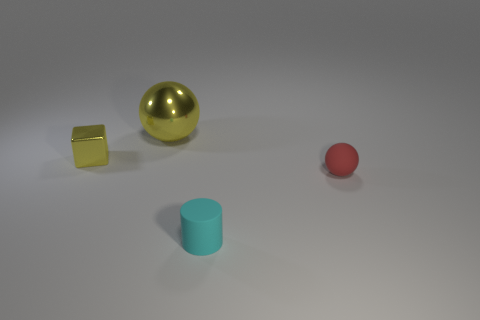What shape is the thing that is both right of the yellow ball and behind the small cyan matte object?
Your response must be concise. Sphere. There is a thing that is on the right side of the cylinder; is its shape the same as the yellow thing left of the large yellow object?
Your answer should be very brief. No. What is the size of the sphere that is to the left of the tiny matte thing on the left side of the sphere in front of the yellow metal ball?
Ensure brevity in your answer.  Large. What is the shape of the red thing that is the same size as the cyan cylinder?
Provide a succinct answer. Sphere. How many matte things are either big brown cylinders or red balls?
Provide a short and direct response. 1. What number of yellow metal objects have the same shape as the red rubber object?
Offer a terse response. 1. What is the material of the tiny cube that is the same color as the large ball?
Offer a very short reply. Metal. There is a shiny object on the left side of the metallic sphere; does it have the same size as the ball right of the large yellow metal object?
Make the answer very short. Yes. The object that is in front of the red thing has what shape?
Offer a terse response. Cylinder. There is a big yellow object that is the same shape as the tiny red object; what is its material?
Your answer should be very brief. Metal. 